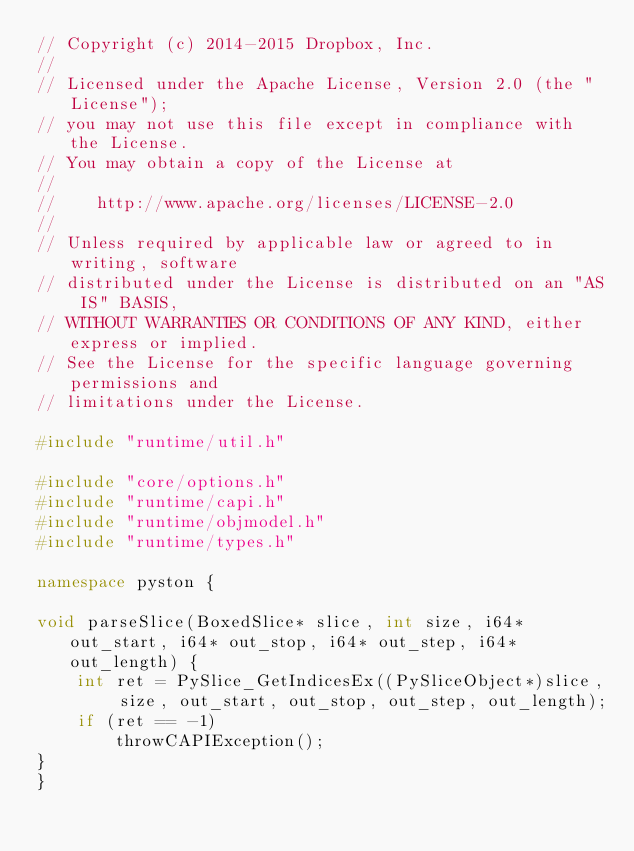<code> <loc_0><loc_0><loc_500><loc_500><_C++_>// Copyright (c) 2014-2015 Dropbox, Inc.
//
// Licensed under the Apache License, Version 2.0 (the "License");
// you may not use this file except in compliance with the License.
// You may obtain a copy of the License at
//
//    http://www.apache.org/licenses/LICENSE-2.0
//
// Unless required by applicable law or agreed to in writing, software
// distributed under the License is distributed on an "AS IS" BASIS,
// WITHOUT WARRANTIES OR CONDITIONS OF ANY KIND, either express or implied.
// See the License for the specific language governing permissions and
// limitations under the License.

#include "runtime/util.h"

#include "core/options.h"
#include "runtime/capi.h"
#include "runtime/objmodel.h"
#include "runtime/types.h"

namespace pyston {

void parseSlice(BoxedSlice* slice, int size, i64* out_start, i64* out_stop, i64* out_step, i64* out_length) {
    int ret = PySlice_GetIndicesEx((PySliceObject*)slice, size, out_start, out_stop, out_step, out_length);
    if (ret == -1)
        throwCAPIException();
}
}
</code> 